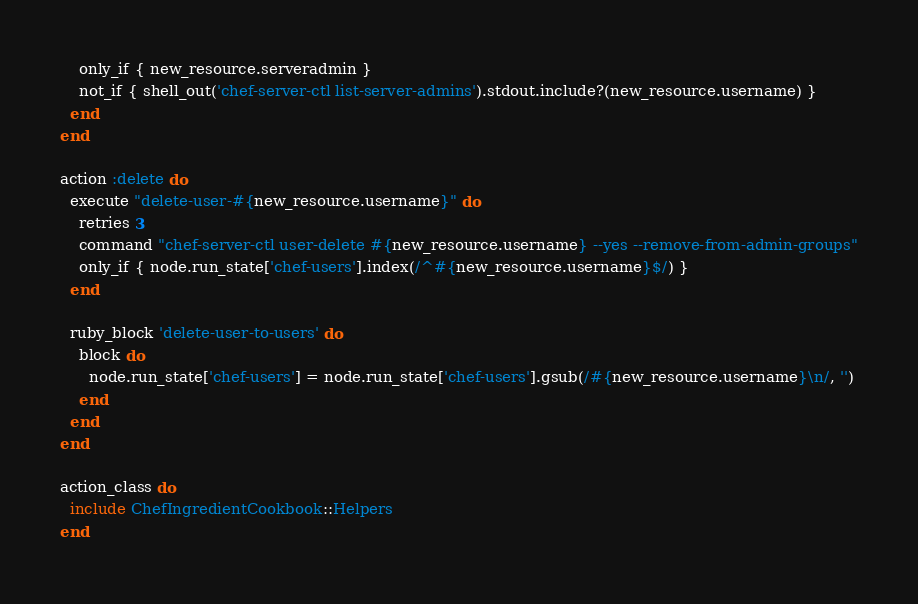Convert code to text. <code><loc_0><loc_0><loc_500><loc_500><_Ruby_>    only_if { new_resource.serveradmin }
    not_if { shell_out('chef-server-ctl list-server-admins').stdout.include?(new_resource.username) }
  end
end

action :delete do
  execute "delete-user-#{new_resource.username}" do
    retries 3
    command "chef-server-ctl user-delete #{new_resource.username} --yes --remove-from-admin-groups"
    only_if { node.run_state['chef-users'].index(/^#{new_resource.username}$/) }
  end

  ruby_block 'delete-user-to-users' do
    block do
      node.run_state['chef-users'] = node.run_state['chef-users'].gsub(/#{new_resource.username}\n/, '')
    end
  end
end

action_class do
  include ChefIngredientCookbook::Helpers
end
</code> 